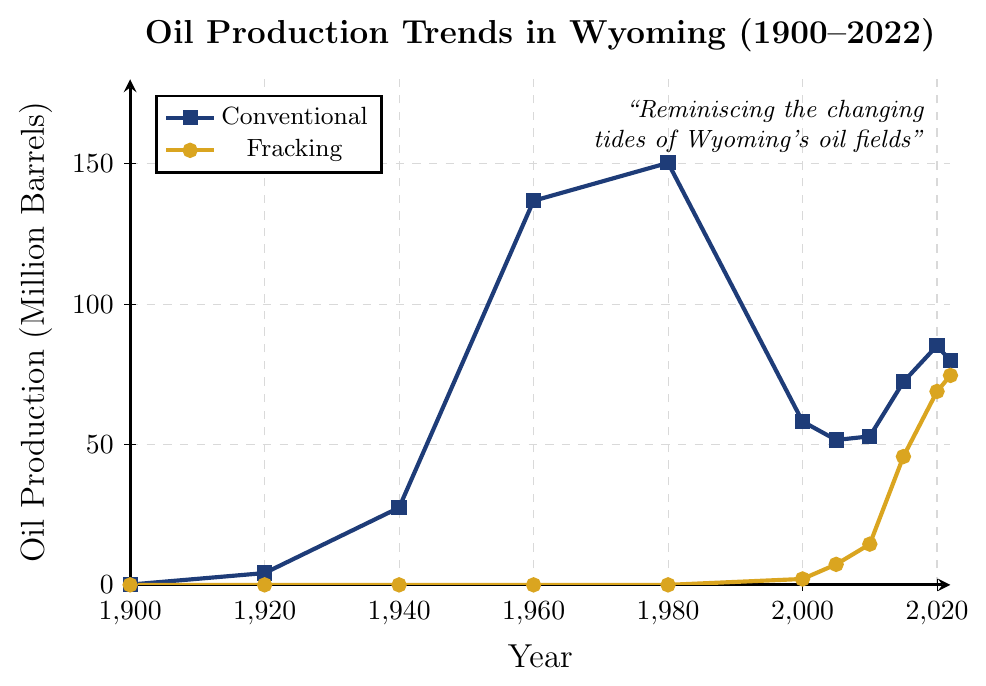What's the highest conventional oil production in Wyoming? The highest conventional oil production can be seen at the peak of the line corresponding to conventional production. This peak is located at the year 1980, reaching up to 150.3 million barrels.
Answer: 150.3 million barrels Which year shows the start of fracking oil production in Wyoming? Fracking oil production starts where the line corresponding to fracking first rises above zero. This first rise above zero can be observed in the year 2000.
Answer: 2000 Compare the production of conventional and fracking oil in 2022. Which method produced more, and by how much? On the chart, in the year 2022, the data points for conventional and fracking oil production are 79.8 and 74.6 million barrels respectively. Comparing these, conventional production (79.8) is higher than fracking (74.6). The difference is 79.8 - 74.6 = 5.2 million barrels.
Answer: Conventional, 5.2 million barrels In which years did conventional oil production decrease compared to the previous year shown on the graph? By closely observing the line for conventional oil production, decreases in production occur between the years 1980 to 2000 (150.3 to 58.2 million barrels) and between 2020 to 2022 (85.2 to 79.8 million barrels).
Answer: 1980 to 2000, 2020 to 2022 What's the general trend of fracking oil production from 2000 to 2022? The line representing fracking oil production shows a general upward trend starting from 2000 with a value of 2.1 million barrels to 2022 with a value of 74.6 million barrels, without any decrease during this period.
Answer: Upward trend Calculate the total oil production (conventional + fracking) in 2010. In 2010, conventional oil production is 52.9 million barrels and fracking oil production is 14.5 million barrels. The total production adds up to 52.9 + 14.5 = 67.4 million barrels.
Answer: 67.4 million barrels How does the rise in fracking oil production between 2005 and 2015 compare to the rise in conventional oil production during the same period? For fracking, the rise from 2005 (7.3 million barrels) to 2015 (45.7 million barrels) is 45.7 - 7.3 = 38.4 million barrels. For conventional, the rise from 2005 (51.6 million barrels) to 2015 (72.3 million barrels) is 72.3 - 51.6 = 20.7 million barrels. Fracking production's rise (38.4) is significantly higher than conventional production's rise (20.7).
Answer: Fracking rise is higher by 17.7 million barrels Describe the color and marker used for the conventional oil production line. The conventional oil production line is represented by a blue line with square markers.
Answer: Blue, square markers Which oil extraction method shows more variability in production over the years? Observing the two lines, conventional oil production shows more variability with several noticeable peaks and drops, especially the significant increase around 1960-1980 and the subsequent decrease by 2000.
Answer: Conventional 